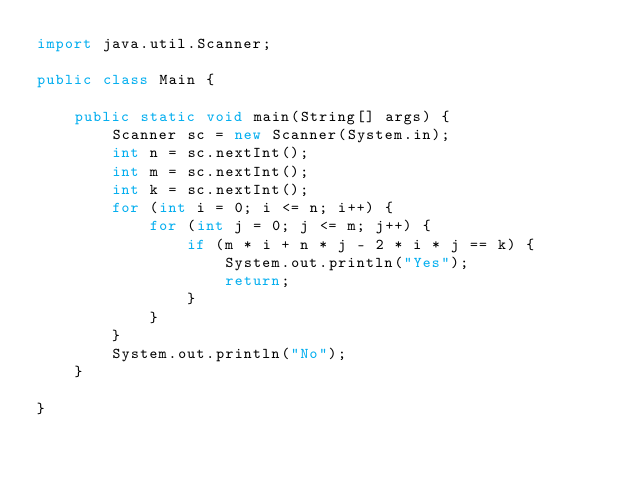Convert code to text. <code><loc_0><loc_0><loc_500><loc_500><_Java_>import java.util.Scanner;

public class Main {

    public static void main(String[] args) {
        Scanner sc = new Scanner(System.in);
        int n = sc.nextInt();
        int m = sc.nextInt();
        int k = sc.nextInt();
        for (int i = 0; i <= n; i++) {
            for (int j = 0; j <= m; j++) {
                if (m * i + n * j - 2 * i * j == k) {
                    System.out.println("Yes");
                    return;
                }
            }
        }
        System.out.println("No");
    }

}
</code> 